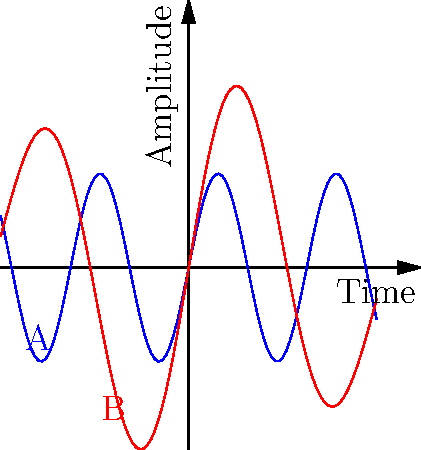Looking at the sound wave patterns represented by these vectors, which instrument do you think produces a more sustained note? To determine which instrument produces a more sustained note, we need to analyze the wave patterns:

1. The blue line (A) represents a guitar sound wave:
   - It shows a consistent sine wave pattern
   - The amplitude remains relatively constant over time

2. The red line (B) represents a violin sound wave:
   - It shows a dampened sine wave pattern
   - The amplitude decreases over time (envelope decay)

3. A sustained note is characterized by:
   - Consistent amplitude over time
   - Longer duration of the sound

4. Comparing the two patterns:
   - The guitar (blue) maintains a consistent amplitude
   - The violin (red) shows a decreasing amplitude

5. In terms of sustain:
   - The guitar pattern indicates a longer-lasting, consistent sound
   - The violin pattern suggests a gradually fading sound

Therefore, based on these vector representations, the guitar produces a more sustained note compared to the violin.
Answer: Guitar 